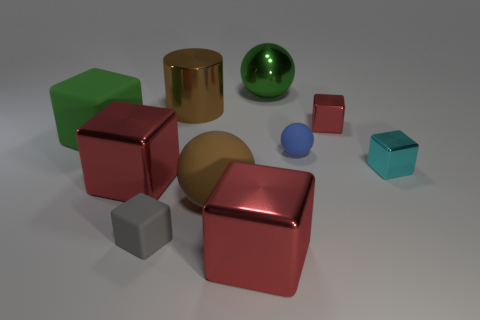Subtract all red cubes. How many were subtracted if there are1red cubes left? 2 Subtract all blue spheres. How many red cubes are left? 3 Subtract all cyan blocks. How many blocks are left? 5 Subtract 3 cubes. How many cubes are left? 3 Subtract all matte cubes. How many cubes are left? 4 Subtract all purple cubes. Subtract all brown cylinders. How many cubes are left? 6 Subtract all spheres. How many objects are left? 7 Subtract all tiny red matte things. Subtract all tiny rubber spheres. How many objects are left? 9 Add 3 large red metal things. How many large red metal things are left? 5 Add 3 big blocks. How many big blocks exist? 6 